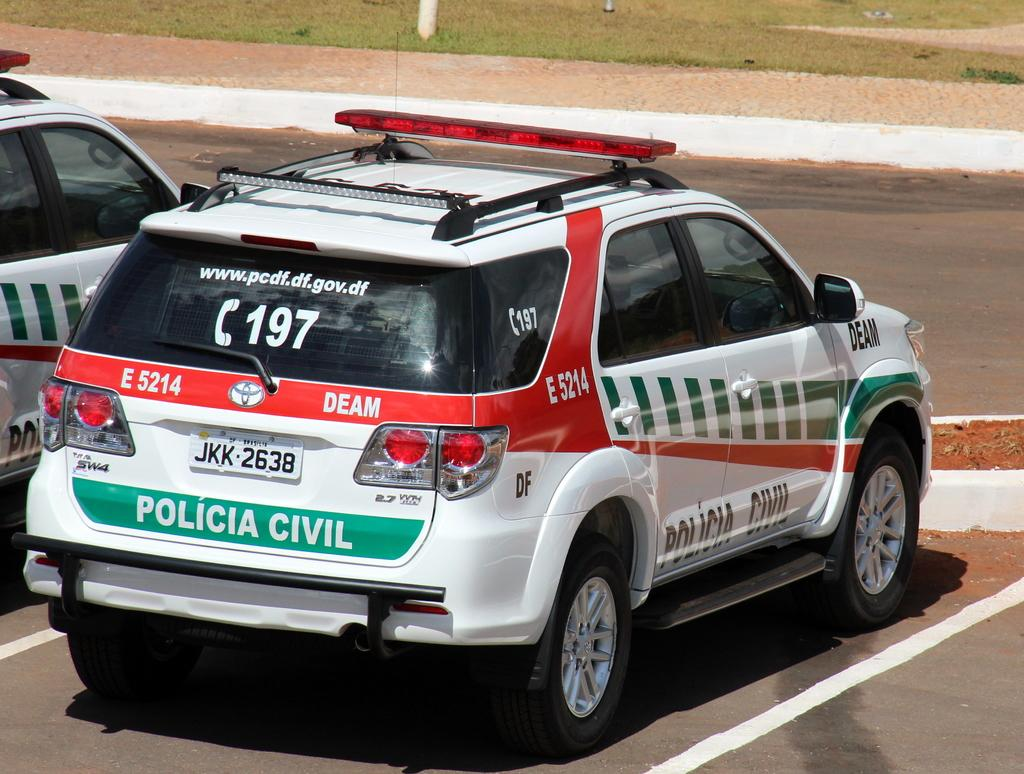What type of vehicle is in the image? There is a police vehicle in the image. What color is the police vehicle? The police vehicle is white. What can be seen written on the police vehicle? There is something written on the police vehicle. What other vehicle is present in the image? There is another vehicle beside the police vehicle. Can you see a cactus growing beside the police vehicle in the image? There is no cactus present in the image. What type of hammer is being used to transport the police vehicle in the image? There is no hammer or transportation activity depicted in the image. 